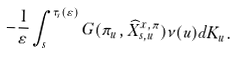<formula> <loc_0><loc_0><loc_500><loc_500>- \frac { 1 } { \varepsilon } \int _ { s } ^ { \tau _ { s } ( \varepsilon ) } G ( \pi _ { u } , \widehat { X } _ { s , u } ^ { x , \pi } ) \nu ( u ) d K _ { u } .</formula> 